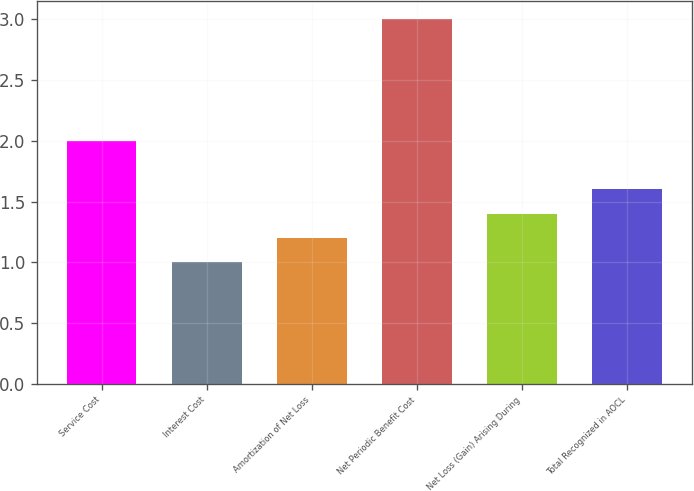Convert chart to OTSL. <chart><loc_0><loc_0><loc_500><loc_500><bar_chart><fcel>Service Cost<fcel>Interest Cost<fcel>Amortization of Net Loss<fcel>Net Periodic Benefit Cost<fcel>Net Loss (Gain) Arising During<fcel>Total Recognized in AOCL<nl><fcel>2<fcel>1<fcel>1.2<fcel>3<fcel>1.4<fcel>1.6<nl></chart> 